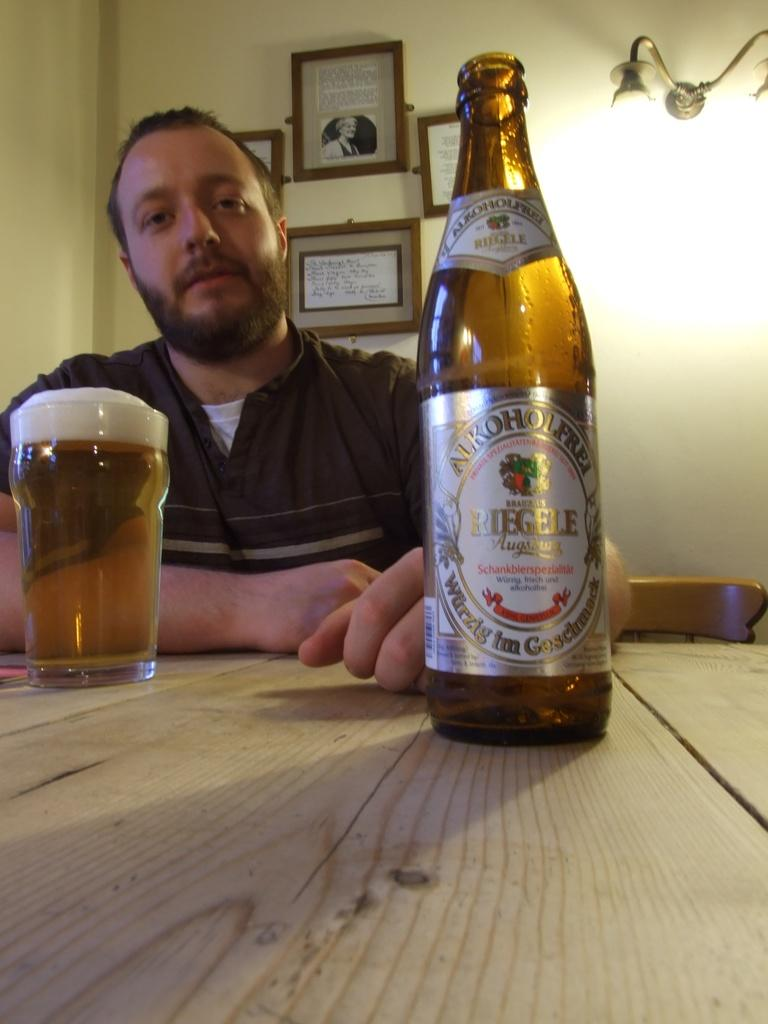<image>
Provide a brief description of the given image. a beer bottle with the word Riegele on it 